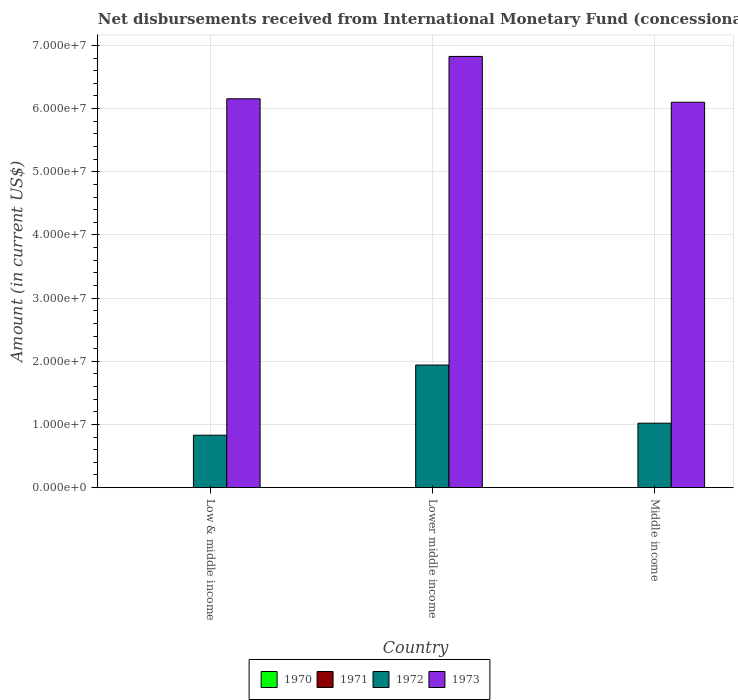How many different coloured bars are there?
Provide a succinct answer. 2. Are the number of bars per tick equal to the number of legend labels?
Make the answer very short. No. Are the number of bars on each tick of the X-axis equal?
Your answer should be very brief. Yes. How many bars are there on the 3rd tick from the right?
Make the answer very short. 2. What is the label of the 2nd group of bars from the left?
Provide a succinct answer. Lower middle income. What is the amount of disbursements received from International Monetary Fund in 1972 in Lower middle income?
Offer a terse response. 1.94e+07. Across all countries, what is the maximum amount of disbursements received from International Monetary Fund in 1973?
Give a very brief answer. 6.83e+07. Across all countries, what is the minimum amount of disbursements received from International Monetary Fund in 1970?
Your response must be concise. 0. In which country was the amount of disbursements received from International Monetary Fund in 1972 maximum?
Ensure brevity in your answer.  Lower middle income. What is the total amount of disbursements received from International Monetary Fund in 1973 in the graph?
Offer a very short reply. 1.91e+08. What is the difference between the amount of disbursements received from International Monetary Fund in 1972 in Lower middle income and that in Middle income?
Give a very brief answer. 9.21e+06. What is the difference between the amount of disbursements received from International Monetary Fund in 1972 in Low & middle income and the amount of disbursements received from International Monetary Fund in 1971 in Lower middle income?
Offer a terse response. 8.30e+06. What is the average amount of disbursements received from International Monetary Fund in 1971 per country?
Ensure brevity in your answer.  0. What is the difference between the amount of disbursements received from International Monetary Fund of/in 1973 and amount of disbursements received from International Monetary Fund of/in 1972 in Middle income?
Keep it short and to the point. 5.08e+07. In how many countries, is the amount of disbursements received from International Monetary Fund in 1971 greater than 4000000 US$?
Provide a short and direct response. 0. What is the ratio of the amount of disbursements received from International Monetary Fund in 1973 in Low & middle income to that in Lower middle income?
Offer a terse response. 0.9. Is the difference between the amount of disbursements received from International Monetary Fund in 1973 in Lower middle income and Middle income greater than the difference between the amount of disbursements received from International Monetary Fund in 1972 in Lower middle income and Middle income?
Keep it short and to the point. No. What is the difference between the highest and the second highest amount of disbursements received from International Monetary Fund in 1973?
Your answer should be very brief. -7.25e+06. What is the difference between the highest and the lowest amount of disbursements received from International Monetary Fund in 1972?
Your answer should be very brief. 1.11e+07. Is it the case that in every country, the sum of the amount of disbursements received from International Monetary Fund in 1973 and amount of disbursements received from International Monetary Fund in 1972 is greater than the sum of amount of disbursements received from International Monetary Fund in 1970 and amount of disbursements received from International Monetary Fund in 1971?
Your answer should be very brief. Yes. How many bars are there?
Your response must be concise. 6. What is the difference between two consecutive major ticks on the Y-axis?
Your answer should be very brief. 1.00e+07. Are the values on the major ticks of Y-axis written in scientific E-notation?
Ensure brevity in your answer.  Yes. Does the graph contain any zero values?
Your answer should be very brief. Yes. Where does the legend appear in the graph?
Offer a terse response. Bottom center. What is the title of the graph?
Provide a succinct answer. Net disbursements received from International Monetary Fund (concessional). What is the label or title of the X-axis?
Provide a short and direct response. Country. What is the label or title of the Y-axis?
Your answer should be very brief. Amount (in current US$). What is the Amount (in current US$) in 1970 in Low & middle income?
Ensure brevity in your answer.  0. What is the Amount (in current US$) of 1971 in Low & middle income?
Offer a terse response. 0. What is the Amount (in current US$) of 1972 in Low & middle income?
Ensure brevity in your answer.  8.30e+06. What is the Amount (in current US$) of 1973 in Low & middle income?
Your answer should be very brief. 6.16e+07. What is the Amount (in current US$) in 1970 in Lower middle income?
Your response must be concise. 0. What is the Amount (in current US$) of 1971 in Lower middle income?
Provide a succinct answer. 0. What is the Amount (in current US$) in 1972 in Lower middle income?
Offer a very short reply. 1.94e+07. What is the Amount (in current US$) of 1973 in Lower middle income?
Ensure brevity in your answer.  6.83e+07. What is the Amount (in current US$) of 1972 in Middle income?
Keep it short and to the point. 1.02e+07. What is the Amount (in current US$) of 1973 in Middle income?
Provide a short and direct response. 6.10e+07. Across all countries, what is the maximum Amount (in current US$) in 1972?
Provide a succinct answer. 1.94e+07. Across all countries, what is the maximum Amount (in current US$) in 1973?
Give a very brief answer. 6.83e+07. Across all countries, what is the minimum Amount (in current US$) in 1972?
Provide a short and direct response. 8.30e+06. Across all countries, what is the minimum Amount (in current US$) of 1973?
Provide a succinct answer. 6.10e+07. What is the total Amount (in current US$) in 1972 in the graph?
Give a very brief answer. 3.79e+07. What is the total Amount (in current US$) of 1973 in the graph?
Provide a succinct answer. 1.91e+08. What is the difference between the Amount (in current US$) of 1972 in Low & middle income and that in Lower middle income?
Your response must be concise. -1.11e+07. What is the difference between the Amount (in current US$) of 1973 in Low & middle income and that in Lower middle income?
Ensure brevity in your answer.  -6.70e+06. What is the difference between the Amount (in current US$) in 1972 in Low & middle income and that in Middle income?
Offer a terse response. -1.90e+06. What is the difference between the Amount (in current US$) of 1973 in Low & middle income and that in Middle income?
Your answer should be very brief. 5.46e+05. What is the difference between the Amount (in current US$) in 1972 in Lower middle income and that in Middle income?
Keep it short and to the point. 9.21e+06. What is the difference between the Amount (in current US$) in 1973 in Lower middle income and that in Middle income?
Offer a very short reply. 7.25e+06. What is the difference between the Amount (in current US$) in 1972 in Low & middle income and the Amount (in current US$) in 1973 in Lower middle income?
Your answer should be compact. -6.00e+07. What is the difference between the Amount (in current US$) in 1972 in Low & middle income and the Amount (in current US$) in 1973 in Middle income?
Provide a succinct answer. -5.27e+07. What is the difference between the Amount (in current US$) in 1972 in Lower middle income and the Amount (in current US$) in 1973 in Middle income?
Provide a succinct answer. -4.16e+07. What is the average Amount (in current US$) of 1971 per country?
Ensure brevity in your answer.  0. What is the average Amount (in current US$) in 1972 per country?
Ensure brevity in your answer.  1.26e+07. What is the average Amount (in current US$) of 1973 per country?
Offer a very short reply. 6.36e+07. What is the difference between the Amount (in current US$) in 1972 and Amount (in current US$) in 1973 in Low & middle income?
Ensure brevity in your answer.  -5.33e+07. What is the difference between the Amount (in current US$) in 1972 and Amount (in current US$) in 1973 in Lower middle income?
Your response must be concise. -4.89e+07. What is the difference between the Amount (in current US$) in 1972 and Amount (in current US$) in 1973 in Middle income?
Provide a succinct answer. -5.08e+07. What is the ratio of the Amount (in current US$) in 1972 in Low & middle income to that in Lower middle income?
Provide a short and direct response. 0.43. What is the ratio of the Amount (in current US$) in 1973 in Low & middle income to that in Lower middle income?
Ensure brevity in your answer.  0.9. What is the ratio of the Amount (in current US$) in 1972 in Low & middle income to that in Middle income?
Give a very brief answer. 0.81. What is the ratio of the Amount (in current US$) in 1973 in Low & middle income to that in Middle income?
Keep it short and to the point. 1.01. What is the ratio of the Amount (in current US$) of 1972 in Lower middle income to that in Middle income?
Give a very brief answer. 1.9. What is the ratio of the Amount (in current US$) of 1973 in Lower middle income to that in Middle income?
Your response must be concise. 1.12. What is the difference between the highest and the second highest Amount (in current US$) in 1972?
Your answer should be very brief. 9.21e+06. What is the difference between the highest and the second highest Amount (in current US$) of 1973?
Provide a short and direct response. 6.70e+06. What is the difference between the highest and the lowest Amount (in current US$) of 1972?
Your answer should be very brief. 1.11e+07. What is the difference between the highest and the lowest Amount (in current US$) in 1973?
Keep it short and to the point. 7.25e+06. 